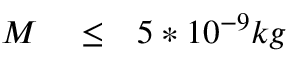Convert formula to latex. <formula><loc_0><loc_0><loc_500><loc_500>\begin{array} { r l r } { M } & \leq } & { 5 * 1 0 ^ { - 9 } k g } \end{array}</formula> 